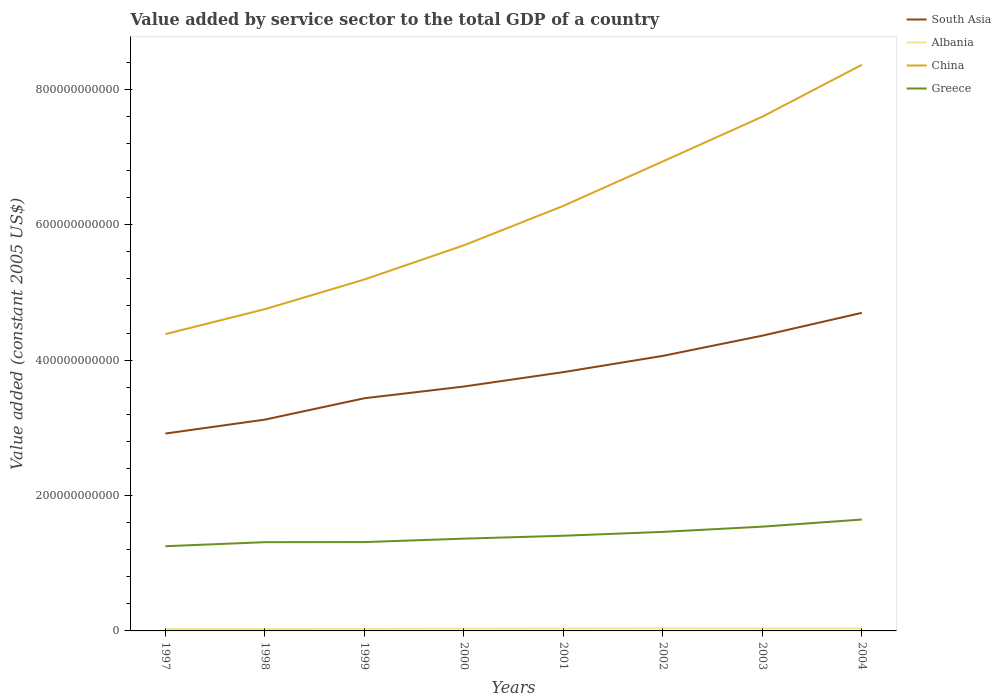Does the line corresponding to Greece intersect with the line corresponding to Albania?
Give a very brief answer. No. Is the number of lines equal to the number of legend labels?
Keep it short and to the point. Yes. Across all years, what is the maximum value added by service sector in Albania?
Give a very brief answer. 2.70e+09. What is the total value added by service sector in Greece in the graph?
Provide a succinct answer. -6.12e+09. What is the difference between the highest and the second highest value added by service sector in Albania?
Give a very brief answer. 1.13e+09. What is the difference between the highest and the lowest value added by service sector in China?
Give a very brief answer. 4. Is the value added by service sector in China strictly greater than the value added by service sector in Greece over the years?
Provide a short and direct response. No. How many years are there in the graph?
Your answer should be compact. 8. What is the difference between two consecutive major ticks on the Y-axis?
Provide a succinct answer. 2.00e+11. Are the values on the major ticks of Y-axis written in scientific E-notation?
Ensure brevity in your answer.  No. How are the legend labels stacked?
Keep it short and to the point. Vertical. What is the title of the graph?
Offer a very short reply. Value added by service sector to the total GDP of a country. What is the label or title of the Y-axis?
Keep it short and to the point. Value added (constant 2005 US$). What is the Value added (constant 2005 US$) in South Asia in 1997?
Offer a very short reply. 2.92e+11. What is the Value added (constant 2005 US$) of Albania in 1997?
Ensure brevity in your answer.  2.70e+09. What is the Value added (constant 2005 US$) of China in 1997?
Ensure brevity in your answer.  4.38e+11. What is the Value added (constant 2005 US$) of Greece in 1997?
Offer a very short reply. 1.25e+11. What is the Value added (constant 2005 US$) of South Asia in 1998?
Your answer should be very brief. 3.12e+11. What is the Value added (constant 2005 US$) in Albania in 1998?
Make the answer very short. 2.73e+09. What is the Value added (constant 2005 US$) in China in 1998?
Make the answer very short. 4.75e+11. What is the Value added (constant 2005 US$) of Greece in 1998?
Make the answer very short. 1.31e+11. What is the Value added (constant 2005 US$) of South Asia in 1999?
Your response must be concise. 3.44e+11. What is the Value added (constant 2005 US$) of Albania in 1999?
Ensure brevity in your answer.  3.14e+09. What is the Value added (constant 2005 US$) in China in 1999?
Keep it short and to the point. 5.19e+11. What is the Value added (constant 2005 US$) of Greece in 1999?
Your answer should be very brief. 1.31e+11. What is the Value added (constant 2005 US$) in South Asia in 2000?
Ensure brevity in your answer.  3.61e+11. What is the Value added (constant 2005 US$) of Albania in 2000?
Keep it short and to the point. 3.28e+09. What is the Value added (constant 2005 US$) in China in 2000?
Keep it short and to the point. 5.70e+11. What is the Value added (constant 2005 US$) of Greece in 2000?
Provide a succinct answer. 1.36e+11. What is the Value added (constant 2005 US$) in South Asia in 2001?
Offer a terse response. 3.82e+11. What is the Value added (constant 2005 US$) in Albania in 2001?
Your answer should be very brief. 3.59e+09. What is the Value added (constant 2005 US$) of China in 2001?
Provide a short and direct response. 6.28e+11. What is the Value added (constant 2005 US$) in Greece in 2001?
Keep it short and to the point. 1.41e+11. What is the Value added (constant 2005 US$) of South Asia in 2002?
Your response must be concise. 4.06e+11. What is the Value added (constant 2005 US$) of Albania in 2002?
Make the answer very short. 3.83e+09. What is the Value added (constant 2005 US$) of China in 2002?
Provide a short and direct response. 6.93e+11. What is the Value added (constant 2005 US$) of Greece in 2002?
Provide a short and direct response. 1.46e+11. What is the Value added (constant 2005 US$) in South Asia in 2003?
Keep it short and to the point. 4.36e+11. What is the Value added (constant 2005 US$) of Albania in 2003?
Your answer should be very brief. 3.63e+09. What is the Value added (constant 2005 US$) of China in 2003?
Ensure brevity in your answer.  7.60e+11. What is the Value added (constant 2005 US$) in Greece in 2003?
Ensure brevity in your answer.  1.54e+11. What is the Value added (constant 2005 US$) in South Asia in 2004?
Offer a terse response. 4.70e+11. What is the Value added (constant 2005 US$) in Albania in 2004?
Your answer should be compact. 3.64e+09. What is the Value added (constant 2005 US$) of China in 2004?
Your response must be concise. 8.36e+11. What is the Value added (constant 2005 US$) in Greece in 2004?
Your answer should be very brief. 1.65e+11. Across all years, what is the maximum Value added (constant 2005 US$) of South Asia?
Offer a terse response. 4.70e+11. Across all years, what is the maximum Value added (constant 2005 US$) in Albania?
Your answer should be compact. 3.83e+09. Across all years, what is the maximum Value added (constant 2005 US$) in China?
Provide a short and direct response. 8.36e+11. Across all years, what is the maximum Value added (constant 2005 US$) of Greece?
Your answer should be very brief. 1.65e+11. Across all years, what is the minimum Value added (constant 2005 US$) of South Asia?
Your answer should be compact. 2.92e+11. Across all years, what is the minimum Value added (constant 2005 US$) of Albania?
Provide a short and direct response. 2.70e+09. Across all years, what is the minimum Value added (constant 2005 US$) in China?
Make the answer very short. 4.38e+11. Across all years, what is the minimum Value added (constant 2005 US$) of Greece?
Your answer should be very brief. 1.25e+11. What is the total Value added (constant 2005 US$) of South Asia in the graph?
Your answer should be very brief. 3.00e+12. What is the total Value added (constant 2005 US$) in Albania in the graph?
Offer a very short reply. 2.65e+1. What is the total Value added (constant 2005 US$) in China in the graph?
Your answer should be compact. 4.92e+12. What is the total Value added (constant 2005 US$) in Greece in the graph?
Your answer should be very brief. 1.13e+12. What is the difference between the Value added (constant 2005 US$) in South Asia in 1997 and that in 1998?
Ensure brevity in your answer.  -2.06e+1. What is the difference between the Value added (constant 2005 US$) in Albania in 1997 and that in 1998?
Provide a succinct answer. -3.40e+07. What is the difference between the Value added (constant 2005 US$) in China in 1997 and that in 1998?
Offer a terse response. -3.68e+1. What is the difference between the Value added (constant 2005 US$) in Greece in 1997 and that in 1998?
Provide a short and direct response. -5.98e+09. What is the difference between the Value added (constant 2005 US$) in South Asia in 1997 and that in 1999?
Provide a short and direct response. -5.21e+1. What is the difference between the Value added (constant 2005 US$) of Albania in 1997 and that in 1999?
Ensure brevity in your answer.  -4.42e+08. What is the difference between the Value added (constant 2005 US$) of China in 1997 and that in 1999?
Offer a terse response. -8.07e+1. What is the difference between the Value added (constant 2005 US$) in Greece in 1997 and that in 1999?
Make the answer very short. -6.12e+09. What is the difference between the Value added (constant 2005 US$) of South Asia in 1997 and that in 2000?
Give a very brief answer. -6.95e+1. What is the difference between the Value added (constant 2005 US$) in Albania in 1997 and that in 2000?
Keep it short and to the point. -5.81e+08. What is the difference between the Value added (constant 2005 US$) of China in 1997 and that in 2000?
Make the answer very short. -1.31e+11. What is the difference between the Value added (constant 2005 US$) of Greece in 1997 and that in 2000?
Your answer should be very brief. -1.12e+1. What is the difference between the Value added (constant 2005 US$) of South Asia in 1997 and that in 2001?
Provide a succinct answer. -9.07e+1. What is the difference between the Value added (constant 2005 US$) of Albania in 1997 and that in 2001?
Keep it short and to the point. -8.90e+08. What is the difference between the Value added (constant 2005 US$) of China in 1997 and that in 2001?
Offer a very short reply. -1.89e+11. What is the difference between the Value added (constant 2005 US$) of Greece in 1997 and that in 2001?
Provide a short and direct response. -1.55e+1. What is the difference between the Value added (constant 2005 US$) of South Asia in 1997 and that in 2002?
Make the answer very short. -1.15e+11. What is the difference between the Value added (constant 2005 US$) in Albania in 1997 and that in 2002?
Ensure brevity in your answer.  -1.13e+09. What is the difference between the Value added (constant 2005 US$) in China in 1997 and that in 2002?
Provide a succinct answer. -2.55e+11. What is the difference between the Value added (constant 2005 US$) in Greece in 1997 and that in 2002?
Your response must be concise. -2.12e+1. What is the difference between the Value added (constant 2005 US$) in South Asia in 1997 and that in 2003?
Offer a terse response. -1.45e+11. What is the difference between the Value added (constant 2005 US$) of Albania in 1997 and that in 2003?
Your response must be concise. -9.35e+08. What is the difference between the Value added (constant 2005 US$) in China in 1997 and that in 2003?
Ensure brevity in your answer.  -3.21e+11. What is the difference between the Value added (constant 2005 US$) of Greece in 1997 and that in 2003?
Make the answer very short. -2.89e+1. What is the difference between the Value added (constant 2005 US$) in South Asia in 1997 and that in 2004?
Keep it short and to the point. -1.78e+11. What is the difference between the Value added (constant 2005 US$) of Albania in 1997 and that in 2004?
Your response must be concise. -9.43e+08. What is the difference between the Value added (constant 2005 US$) in China in 1997 and that in 2004?
Ensure brevity in your answer.  -3.98e+11. What is the difference between the Value added (constant 2005 US$) of Greece in 1997 and that in 2004?
Your response must be concise. -3.94e+1. What is the difference between the Value added (constant 2005 US$) of South Asia in 1998 and that in 1999?
Provide a short and direct response. -3.15e+1. What is the difference between the Value added (constant 2005 US$) in Albania in 1998 and that in 1999?
Provide a succinct answer. -4.08e+08. What is the difference between the Value added (constant 2005 US$) of China in 1998 and that in 1999?
Offer a very short reply. -4.38e+1. What is the difference between the Value added (constant 2005 US$) of Greece in 1998 and that in 1999?
Offer a terse response. -1.37e+08. What is the difference between the Value added (constant 2005 US$) of South Asia in 1998 and that in 2000?
Provide a succinct answer. -4.89e+1. What is the difference between the Value added (constant 2005 US$) in Albania in 1998 and that in 2000?
Give a very brief answer. -5.47e+08. What is the difference between the Value added (constant 2005 US$) of China in 1998 and that in 2000?
Your answer should be very brief. -9.43e+1. What is the difference between the Value added (constant 2005 US$) of Greece in 1998 and that in 2000?
Ensure brevity in your answer.  -5.21e+09. What is the difference between the Value added (constant 2005 US$) in South Asia in 1998 and that in 2001?
Provide a short and direct response. -7.01e+1. What is the difference between the Value added (constant 2005 US$) in Albania in 1998 and that in 2001?
Make the answer very short. -8.56e+08. What is the difference between the Value added (constant 2005 US$) in China in 1998 and that in 2001?
Offer a very short reply. -1.53e+11. What is the difference between the Value added (constant 2005 US$) in Greece in 1998 and that in 2001?
Keep it short and to the point. -9.50e+09. What is the difference between the Value added (constant 2005 US$) of South Asia in 1998 and that in 2002?
Your answer should be very brief. -9.41e+1. What is the difference between the Value added (constant 2005 US$) in Albania in 1998 and that in 2002?
Your response must be concise. -1.10e+09. What is the difference between the Value added (constant 2005 US$) of China in 1998 and that in 2002?
Ensure brevity in your answer.  -2.18e+11. What is the difference between the Value added (constant 2005 US$) of Greece in 1998 and that in 2002?
Offer a terse response. -1.52e+1. What is the difference between the Value added (constant 2005 US$) of South Asia in 1998 and that in 2003?
Offer a terse response. -1.24e+11. What is the difference between the Value added (constant 2005 US$) in Albania in 1998 and that in 2003?
Your answer should be compact. -9.01e+08. What is the difference between the Value added (constant 2005 US$) in China in 1998 and that in 2003?
Make the answer very short. -2.84e+11. What is the difference between the Value added (constant 2005 US$) in Greece in 1998 and that in 2003?
Keep it short and to the point. -2.29e+1. What is the difference between the Value added (constant 2005 US$) of South Asia in 1998 and that in 2004?
Offer a terse response. -1.58e+11. What is the difference between the Value added (constant 2005 US$) of Albania in 1998 and that in 2004?
Offer a terse response. -9.09e+08. What is the difference between the Value added (constant 2005 US$) in China in 1998 and that in 2004?
Your answer should be very brief. -3.61e+11. What is the difference between the Value added (constant 2005 US$) in Greece in 1998 and that in 2004?
Your answer should be very brief. -3.34e+1. What is the difference between the Value added (constant 2005 US$) in South Asia in 1999 and that in 2000?
Offer a terse response. -1.74e+1. What is the difference between the Value added (constant 2005 US$) in Albania in 1999 and that in 2000?
Your response must be concise. -1.39e+08. What is the difference between the Value added (constant 2005 US$) in China in 1999 and that in 2000?
Offer a very short reply. -5.05e+1. What is the difference between the Value added (constant 2005 US$) in Greece in 1999 and that in 2000?
Offer a very short reply. -5.07e+09. What is the difference between the Value added (constant 2005 US$) in South Asia in 1999 and that in 2001?
Your answer should be compact. -3.86e+1. What is the difference between the Value added (constant 2005 US$) of Albania in 1999 and that in 2001?
Give a very brief answer. -4.49e+08. What is the difference between the Value added (constant 2005 US$) of China in 1999 and that in 2001?
Your answer should be compact. -1.09e+11. What is the difference between the Value added (constant 2005 US$) of Greece in 1999 and that in 2001?
Make the answer very short. -9.36e+09. What is the difference between the Value added (constant 2005 US$) of South Asia in 1999 and that in 2002?
Your answer should be very brief. -6.26e+1. What is the difference between the Value added (constant 2005 US$) of Albania in 1999 and that in 2002?
Make the answer very short. -6.91e+08. What is the difference between the Value added (constant 2005 US$) of China in 1999 and that in 2002?
Provide a succinct answer. -1.74e+11. What is the difference between the Value added (constant 2005 US$) of Greece in 1999 and that in 2002?
Make the answer very short. -1.51e+1. What is the difference between the Value added (constant 2005 US$) in South Asia in 1999 and that in 2003?
Offer a terse response. -9.25e+1. What is the difference between the Value added (constant 2005 US$) in Albania in 1999 and that in 2003?
Offer a very short reply. -4.93e+08. What is the difference between the Value added (constant 2005 US$) of China in 1999 and that in 2003?
Your response must be concise. -2.40e+11. What is the difference between the Value added (constant 2005 US$) of Greece in 1999 and that in 2003?
Your answer should be compact. -2.28e+1. What is the difference between the Value added (constant 2005 US$) in South Asia in 1999 and that in 2004?
Offer a terse response. -1.26e+11. What is the difference between the Value added (constant 2005 US$) in Albania in 1999 and that in 2004?
Your answer should be compact. -5.02e+08. What is the difference between the Value added (constant 2005 US$) of China in 1999 and that in 2004?
Offer a very short reply. -3.17e+11. What is the difference between the Value added (constant 2005 US$) of Greece in 1999 and that in 2004?
Offer a terse response. -3.33e+1. What is the difference between the Value added (constant 2005 US$) of South Asia in 2000 and that in 2001?
Your answer should be very brief. -2.13e+1. What is the difference between the Value added (constant 2005 US$) in Albania in 2000 and that in 2001?
Your answer should be very brief. -3.10e+08. What is the difference between the Value added (constant 2005 US$) in China in 2000 and that in 2001?
Give a very brief answer. -5.83e+1. What is the difference between the Value added (constant 2005 US$) in Greece in 2000 and that in 2001?
Offer a very short reply. -4.28e+09. What is the difference between the Value added (constant 2005 US$) in South Asia in 2000 and that in 2002?
Provide a succinct answer. -4.53e+1. What is the difference between the Value added (constant 2005 US$) of Albania in 2000 and that in 2002?
Offer a terse response. -5.52e+08. What is the difference between the Value added (constant 2005 US$) in China in 2000 and that in 2002?
Keep it short and to the point. -1.24e+11. What is the difference between the Value added (constant 2005 US$) in Greece in 2000 and that in 2002?
Give a very brief answer. -1.00e+1. What is the difference between the Value added (constant 2005 US$) in South Asia in 2000 and that in 2003?
Your answer should be compact. -7.51e+1. What is the difference between the Value added (constant 2005 US$) of Albania in 2000 and that in 2003?
Offer a terse response. -3.54e+08. What is the difference between the Value added (constant 2005 US$) of China in 2000 and that in 2003?
Keep it short and to the point. -1.90e+11. What is the difference between the Value added (constant 2005 US$) in Greece in 2000 and that in 2003?
Keep it short and to the point. -1.77e+1. What is the difference between the Value added (constant 2005 US$) of South Asia in 2000 and that in 2004?
Offer a very short reply. -1.09e+11. What is the difference between the Value added (constant 2005 US$) of Albania in 2000 and that in 2004?
Offer a terse response. -3.62e+08. What is the difference between the Value added (constant 2005 US$) of China in 2000 and that in 2004?
Offer a terse response. -2.67e+11. What is the difference between the Value added (constant 2005 US$) of Greece in 2000 and that in 2004?
Provide a short and direct response. -2.82e+1. What is the difference between the Value added (constant 2005 US$) in South Asia in 2001 and that in 2002?
Offer a terse response. -2.40e+1. What is the difference between the Value added (constant 2005 US$) of Albania in 2001 and that in 2002?
Make the answer very short. -2.42e+08. What is the difference between the Value added (constant 2005 US$) of China in 2001 and that in 2002?
Give a very brief answer. -6.57e+1. What is the difference between the Value added (constant 2005 US$) in Greece in 2001 and that in 2002?
Your answer should be very brief. -5.72e+09. What is the difference between the Value added (constant 2005 US$) in South Asia in 2001 and that in 2003?
Offer a terse response. -5.39e+1. What is the difference between the Value added (constant 2005 US$) of Albania in 2001 and that in 2003?
Your response must be concise. -4.42e+07. What is the difference between the Value added (constant 2005 US$) of China in 2001 and that in 2003?
Your response must be concise. -1.32e+11. What is the difference between the Value added (constant 2005 US$) in Greece in 2001 and that in 2003?
Your answer should be very brief. -1.34e+1. What is the difference between the Value added (constant 2005 US$) of South Asia in 2001 and that in 2004?
Give a very brief answer. -8.76e+1. What is the difference between the Value added (constant 2005 US$) of Albania in 2001 and that in 2004?
Your answer should be very brief. -5.27e+07. What is the difference between the Value added (constant 2005 US$) of China in 2001 and that in 2004?
Your response must be concise. -2.08e+11. What is the difference between the Value added (constant 2005 US$) in Greece in 2001 and that in 2004?
Your answer should be compact. -2.40e+1. What is the difference between the Value added (constant 2005 US$) of South Asia in 2002 and that in 2003?
Your answer should be very brief. -2.99e+1. What is the difference between the Value added (constant 2005 US$) in Albania in 2002 and that in 2003?
Offer a very short reply. 1.98e+08. What is the difference between the Value added (constant 2005 US$) of China in 2002 and that in 2003?
Your response must be concise. -6.61e+1. What is the difference between the Value added (constant 2005 US$) of Greece in 2002 and that in 2003?
Keep it short and to the point. -7.70e+09. What is the difference between the Value added (constant 2005 US$) of South Asia in 2002 and that in 2004?
Your response must be concise. -6.36e+1. What is the difference between the Value added (constant 2005 US$) of Albania in 2002 and that in 2004?
Make the answer very short. 1.90e+08. What is the difference between the Value added (constant 2005 US$) in China in 2002 and that in 2004?
Your response must be concise. -1.43e+11. What is the difference between the Value added (constant 2005 US$) of Greece in 2002 and that in 2004?
Offer a terse response. -1.82e+1. What is the difference between the Value added (constant 2005 US$) in South Asia in 2003 and that in 2004?
Offer a terse response. -3.37e+1. What is the difference between the Value added (constant 2005 US$) of Albania in 2003 and that in 2004?
Your answer should be compact. -8.49e+06. What is the difference between the Value added (constant 2005 US$) of China in 2003 and that in 2004?
Provide a succinct answer. -7.66e+1. What is the difference between the Value added (constant 2005 US$) in Greece in 2003 and that in 2004?
Keep it short and to the point. -1.05e+1. What is the difference between the Value added (constant 2005 US$) in South Asia in 1997 and the Value added (constant 2005 US$) in Albania in 1998?
Keep it short and to the point. 2.89e+11. What is the difference between the Value added (constant 2005 US$) of South Asia in 1997 and the Value added (constant 2005 US$) of China in 1998?
Give a very brief answer. -1.84e+11. What is the difference between the Value added (constant 2005 US$) of South Asia in 1997 and the Value added (constant 2005 US$) of Greece in 1998?
Provide a short and direct response. 1.60e+11. What is the difference between the Value added (constant 2005 US$) of Albania in 1997 and the Value added (constant 2005 US$) of China in 1998?
Offer a very short reply. -4.73e+11. What is the difference between the Value added (constant 2005 US$) of Albania in 1997 and the Value added (constant 2005 US$) of Greece in 1998?
Offer a very short reply. -1.28e+11. What is the difference between the Value added (constant 2005 US$) in China in 1997 and the Value added (constant 2005 US$) in Greece in 1998?
Provide a short and direct response. 3.07e+11. What is the difference between the Value added (constant 2005 US$) in South Asia in 1997 and the Value added (constant 2005 US$) in Albania in 1999?
Ensure brevity in your answer.  2.88e+11. What is the difference between the Value added (constant 2005 US$) in South Asia in 1997 and the Value added (constant 2005 US$) in China in 1999?
Your response must be concise. -2.28e+11. What is the difference between the Value added (constant 2005 US$) in South Asia in 1997 and the Value added (constant 2005 US$) in Greece in 1999?
Ensure brevity in your answer.  1.60e+11. What is the difference between the Value added (constant 2005 US$) of Albania in 1997 and the Value added (constant 2005 US$) of China in 1999?
Offer a terse response. -5.16e+11. What is the difference between the Value added (constant 2005 US$) of Albania in 1997 and the Value added (constant 2005 US$) of Greece in 1999?
Keep it short and to the point. -1.29e+11. What is the difference between the Value added (constant 2005 US$) of China in 1997 and the Value added (constant 2005 US$) of Greece in 1999?
Keep it short and to the point. 3.07e+11. What is the difference between the Value added (constant 2005 US$) in South Asia in 1997 and the Value added (constant 2005 US$) in Albania in 2000?
Your answer should be compact. 2.88e+11. What is the difference between the Value added (constant 2005 US$) in South Asia in 1997 and the Value added (constant 2005 US$) in China in 2000?
Provide a short and direct response. -2.78e+11. What is the difference between the Value added (constant 2005 US$) of South Asia in 1997 and the Value added (constant 2005 US$) of Greece in 2000?
Your answer should be compact. 1.55e+11. What is the difference between the Value added (constant 2005 US$) in Albania in 1997 and the Value added (constant 2005 US$) in China in 2000?
Your answer should be very brief. -5.67e+11. What is the difference between the Value added (constant 2005 US$) in Albania in 1997 and the Value added (constant 2005 US$) in Greece in 2000?
Keep it short and to the point. -1.34e+11. What is the difference between the Value added (constant 2005 US$) in China in 1997 and the Value added (constant 2005 US$) in Greece in 2000?
Your answer should be very brief. 3.02e+11. What is the difference between the Value added (constant 2005 US$) in South Asia in 1997 and the Value added (constant 2005 US$) in Albania in 2001?
Provide a short and direct response. 2.88e+11. What is the difference between the Value added (constant 2005 US$) of South Asia in 1997 and the Value added (constant 2005 US$) of China in 2001?
Keep it short and to the point. -3.36e+11. What is the difference between the Value added (constant 2005 US$) of South Asia in 1997 and the Value added (constant 2005 US$) of Greece in 2001?
Keep it short and to the point. 1.51e+11. What is the difference between the Value added (constant 2005 US$) of Albania in 1997 and the Value added (constant 2005 US$) of China in 2001?
Your response must be concise. -6.25e+11. What is the difference between the Value added (constant 2005 US$) in Albania in 1997 and the Value added (constant 2005 US$) in Greece in 2001?
Keep it short and to the point. -1.38e+11. What is the difference between the Value added (constant 2005 US$) in China in 1997 and the Value added (constant 2005 US$) in Greece in 2001?
Offer a very short reply. 2.98e+11. What is the difference between the Value added (constant 2005 US$) in South Asia in 1997 and the Value added (constant 2005 US$) in Albania in 2002?
Your answer should be compact. 2.88e+11. What is the difference between the Value added (constant 2005 US$) of South Asia in 1997 and the Value added (constant 2005 US$) of China in 2002?
Give a very brief answer. -4.02e+11. What is the difference between the Value added (constant 2005 US$) of South Asia in 1997 and the Value added (constant 2005 US$) of Greece in 2002?
Your answer should be compact. 1.45e+11. What is the difference between the Value added (constant 2005 US$) of Albania in 1997 and the Value added (constant 2005 US$) of China in 2002?
Make the answer very short. -6.91e+11. What is the difference between the Value added (constant 2005 US$) of Albania in 1997 and the Value added (constant 2005 US$) of Greece in 2002?
Offer a very short reply. -1.44e+11. What is the difference between the Value added (constant 2005 US$) in China in 1997 and the Value added (constant 2005 US$) in Greece in 2002?
Make the answer very short. 2.92e+11. What is the difference between the Value added (constant 2005 US$) of South Asia in 1997 and the Value added (constant 2005 US$) of Albania in 2003?
Provide a succinct answer. 2.88e+11. What is the difference between the Value added (constant 2005 US$) in South Asia in 1997 and the Value added (constant 2005 US$) in China in 2003?
Ensure brevity in your answer.  -4.68e+11. What is the difference between the Value added (constant 2005 US$) in South Asia in 1997 and the Value added (constant 2005 US$) in Greece in 2003?
Offer a very short reply. 1.38e+11. What is the difference between the Value added (constant 2005 US$) of Albania in 1997 and the Value added (constant 2005 US$) of China in 2003?
Keep it short and to the point. -7.57e+11. What is the difference between the Value added (constant 2005 US$) in Albania in 1997 and the Value added (constant 2005 US$) in Greece in 2003?
Make the answer very short. -1.51e+11. What is the difference between the Value added (constant 2005 US$) in China in 1997 and the Value added (constant 2005 US$) in Greece in 2003?
Keep it short and to the point. 2.84e+11. What is the difference between the Value added (constant 2005 US$) of South Asia in 1997 and the Value added (constant 2005 US$) of Albania in 2004?
Keep it short and to the point. 2.88e+11. What is the difference between the Value added (constant 2005 US$) of South Asia in 1997 and the Value added (constant 2005 US$) of China in 2004?
Provide a short and direct response. -5.45e+11. What is the difference between the Value added (constant 2005 US$) of South Asia in 1997 and the Value added (constant 2005 US$) of Greece in 2004?
Give a very brief answer. 1.27e+11. What is the difference between the Value added (constant 2005 US$) in Albania in 1997 and the Value added (constant 2005 US$) in China in 2004?
Your response must be concise. -8.34e+11. What is the difference between the Value added (constant 2005 US$) of Albania in 1997 and the Value added (constant 2005 US$) of Greece in 2004?
Your answer should be compact. -1.62e+11. What is the difference between the Value added (constant 2005 US$) in China in 1997 and the Value added (constant 2005 US$) in Greece in 2004?
Ensure brevity in your answer.  2.74e+11. What is the difference between the Value added (constant 2005 US$) in South Asia in 1998 and the Value added (constant 2005 US$) in Albania in 1999?
Provide a succinct answer. 3.09e+11. What is the difference between the Value added (constant 2005 US$) in South Asia in 1998 and the Value added (constant 2005 US$) in China in 1999?
Provide a short and direct response. -2.07e+11. What is the difference between the Value added (constant 2005 US$) of South Asia in 1998 and the Value added (constant 2005 US$) of Greece in 1999?
Ensure brevity in your answer.  1.81e+11. What is the difference between the Value added (constant 2005 US$) in Albania in 1998 and the Value added (constant 2005 US$) in China in 1999?
Give a very brief answer. -5.16e+11. What is the difference between the Value added (constant 2005 US$) of Albania in 1998 and the Value added (constant 2005 US$) of Greece in 1999?
Provide a succinct answer. -1.28e+11. What is the difference between the Value added (constant 2005 US$) in China in 1998 and the Value added (constant 2005 US$) in Greece in 1999?
Keep it short and to the point. 3.44e+11. What is the difference between the Value added (constant 2005 US$) in South Asia in 1998 and the Value added (constant 2005 US$) in Albania in 2000?
Provide a succinct answer. 3.09e+11. What is the difference between the Value added (constant 2005 US$) of South Asia in 1998 and the Value added (constant 2005 US$) of China in 2000?
Offer a terse response. -2.57e+11. What is the difference between the Value added (constant 2005 US$) of South Asia in 1998 and the Value added (constant 2005 US$) of Greece in 2000?
Ensure brevity in your answer.  1.76e+11. What is the difference between the Value added (constant 2005 US$) of Albania in 1998 and the Value added (constant 2005 US$) of China in 2000?
Provide a succinct answer. -5.67e+11. What is the difference between the Value added (constant 2005 US$) of Albania in 1998 and the Value added (constant 2005 US$) of Greece in 2000?
Your response must be concise. -1.34e+11. What is the difference between the Value added (constant 2005 US$) in China in 1998 and the Value added (constant 2005 US$) in Greece in 2000?
Your answer should be very brief. 3.39e+11. What is the difference between the Value added (constant 2005 US$) of South Asia in 1998 and the Value added (constant 2005 US$) of Albania in 2001?
Your answer should be very brief. 3.09e+11. What is the difference between the Value added (constant 2005 US$) of South Asia in 1998 and the Value added (constant 2005 US$) of China in 2001?
Your answer should be compact. -3.16e+11. What is the difference between the Value added (constant 2005 US$) in South Asia in 1998 and the Value added (constant 2005 US$) in Greece in 2001?
Offer a very short reply. 1.72e+11. What is the difference between the Value added (constant 2005 US$) in Albania in 1998 and the Value added (constant 2005 US$) in China in 2001?
Give a very brief answer. -6.25e+11. What is the difference between the Value added (constant 2005 US$) of Albania in 1998 and the Value added (constant 2005 US$) of Greece in 2001?
Your response must be concise. -1.38e+11. What is the difference between the Value added (constant 2005 US$) of China in 1998 and the Value added (constant 2005 US$) of Greece in 2001?
Provide a succinct answer. 3.35e+11. What is the difference between the Value added (constant 2005 US$) in South Asia in 1998 and the Value added (constant 2005 US$) in Albania in 2002?
Your response must be concise. 3.08e+11. What is the difference between the Value added (constant 2005 US$) of South Asia in 1998 and the Value added (constant 2005 US$) of China in 2002?
Provide a short and direct response. -3.81e+11. What is the difference between the Value added (constant 2005 US$) in South Asia in 1998 and the Value added (constant 2005 US$) in Greece in 2002?
Your answer should be very brief. 1.66e+11. What is the difference between the Value added (constant 2005 US$) of Albania in 1998 and the Value added (constant 2005 US$) of China in 2002?
Give a very brief answer. -6.91e+11. What is the difference between the Value added (constant 2005 US$) in Albania in 1998 and the Value added (constant 2005 US$) in Greece in 2002?
Offer a very short reply. -1.44e+11. What is the difference between the Value added (constant 2005 US$) in China in 1998 and the Value added (constant 2005 US$) in Greece in 2002?
Make the answer very short. 3.29e+11. What is the difference between the Value added (constant 2005 US$) of South Asia in 1998 and the Value added (constant 2005 US$) of Albania in 2003?
Give a very brief answer. 3.08e+11. What is the difference between the Value added (constant 2005 US$) in South Asia in 1998 and the Value added (constant 2005 US$) in China in 2003?
Keep it short and to the point. -4.47e+11. What is the difference between the Value added (constant 2005 US$) in South Asia in 1998 and the Value added (constant 2005 US$) in Greece in 2003?
Your answer should be very brief. 1.58e+11. What is the difference between the Value added (constant 2005 US$) of Albania in 1998 and the Value added (constant 2005 US$) of China in 2003?
Provide a succinct answer. -7.57e+11. What is the difference between the Value added (constant 2005 US$) of Albania in 1998 and the Value added (constant 2005 US$) of Greece in 2003?
Offer a terse response. -1.51e+11. What is the difference between the Value added (constant 2005 US$) of China in 1998 and the Value added (constant 2005 US$) of Greece in 2003?
Keep it short and to the point. 3.21e+11. What is the difference between the Value added (constant 2005 US$) of South Asia in 1998 and the Value added (constant 2005 US$) of Albania in 2004?
Ensure brevity in your answer.  3.08e+11. What is the difference between the Value added (constant 2005 US$) in South Asia in 1998 and the Value added (constant 2005 US$) in China in 2004?
Your response must be concise. -5.24e+11. What is the difference between the Value added (constant 2005 US$) of South Asia in 1998 and the Value added (constant 2005 US$) of Greece in 2004?
Your response must be concise. 1.48e+11. What is the difference between the Value added (constant 2005 US$) in Albania in 1998 and the Value added (constant 2005 US$) in China in 2004?
Your answer should be compact. -8.33e+11. What is the difference between the Value added (constant 2005 US$) of Albania in 1998 and the Value added (constant 2005 US$) of Greece in 2004?
Ensure brevity in your answer.  -1.62e+11. What is the difference between the Value added (constant 2005 US$) of China in 1998 and the Value added (constant 2005 US$) of Greece in 2004?
Make the answer very short. 3.11e+11. What is the difference between the Value added (constant 2005 US$) of South Asia in 1999 and the Value added (constant 2005 US$) of Albania in 2000?
Ensure brevity in your answer.  3.40e+11. What is the difference between the Value added (constant 2005 US$) in South Asia in 1999 and the Value added (constant 2005 US$) in China in 2000?
Ensure brevity in your answer.  -2.26e+11. What is the difference between the Value added (constant 2005 US$) in South Asia in 1999 and the Value added (constant 2005 US$) in Greece in 2000?
Provide a short and direct response. 2.07e+11. What is the difference between the Value added (constant 2005 US$) of Albania in 1999 and the Value added (constant 2005 US$) of China in 2000?
Keep it short and to the point. -5.66e+11. What is the difference between the Value added (constant 2005 US$) in Albania in 1999 and the Value added (constant 2005 US$) in Greece in 2000?
Your response must be concise. -1.33e+11. What is the difference between the Value added (constant 2005 US$) in China in 1999 and the Value added (constant 2005 US$) in Greece in 2000?
Your answer should be compact. 3.83e+11. What is the difference between the Value added (constant 2005 US$) in South Asia in 1999 and the Value added (constant 2005 US$) in Albania in 2001?
Give a very brief answer. 3.40e+11. What is the difference between the Value added (constant 2005 US$) of South Asia in 1999 and the Value added (constant 2005 US$) of China in 2001?
Provide a short and direct response. -2.84e+11. What is the difference between the Value added (constant 2005 US$) of South Asia in 1999 and the Value added (constant 2005 US$) of Greece in 2001?
Ensure brevity in your answer.  2.03e+11. What is the difference between the Value added (constant 2005 US$) in Albania in 1999 and the Value added (constant 2005 US$) in China in 2001?
Ensure brevity in your answer.  -6.25e+11. What is the difference between the Value added (constant 2005 US$) of Albania in 1999 and the Value added (constant 2005 US$) of Greece in 2001?
Your answer should be compact. -1.37e+11. What is the difference between the Value added (constant 2005 US$) in China in 1999 and the Value added (constant 2005 US$) in Greece in 2001?
Your answer should be compact. 3.78e+11. What is the difference between the Value added (constant 2005 US$) of South Asia in 1999 and the Value added (constant 2005 US$) of Albania in 2002?
Your response must be concise. 3.40e+11. What is the difference between the Value added (constant 2005 US$) of South Asia in 1999 and the Value added (constant 2005 US$) of China in 2002?
Keep it short and to the point. -3.50e+11. What is the difference between the Value added (constant 2005 US$) in South Asia in 1999 and the Value added (constant 2005 US$) in Greece in 2002?
Your response must be concise. 1.97e+11. What is the difference between the Value added (constant 2005 US$) of Albania in 1999 and the Value added (constant 2005 US$) of China in 2002?
Your answer should be very brief. -6.90e+11. What is the difference between the Value added (constant 2005 US$) in Albania in 1999 and the Value added (constant 2005 US$) in Greece in 2002?
Give a very brief answer. -1.43e+11. What is the difference between the Value added (constant 2005 US$) of China in 1999 and the Value added (constant 2005 US$) of Greece in 2002?
Make the answer very short. 3.73e+11. What is the difference between the Value added (constant 2005 US$) of South Asia in 1999 and the Value added (constant 2005 US$) of Albania in 2003?
Keep it short and to the point. 3.40e+11. What is the difference between the Value added (constant 2005 US$) of South Asia in 1999 and the Value added (constant 2005 US$) of China in 2003?
Make the answer very short. -4.16e+11. What is the difference between the Value added (constant 2005 US$) of South Asia in 1999 and the Value added (constant 2005 US$) of Greece in 2003?
Provide a succinct answer. 1.90e+11. What is the difference between the Value added (constant 2005 US$) of Albania in 1999 and the Value added (constant 2005 US$) of China in 2003?
Offer a very short reply. -7.56e+11. What is the difference between the Value added (constant 2005 US$) of Albania in 1999 and the Value added (constant 2005 US$) of Greece in 2003?
Give a very brief answer. -1.51e+11. What is the difference between the Value added (constant 2005 US$) in China in 1999 and the Value added (constant 2005 US$) in Greece in 2003?
Give a very brief answer. 3.65e+11. What is the difference between the Value added (constant 2005 US$) of South Asia in 1999 and the Value added (constant 2005 US$) of Albania in 2004?
Your response must be concise. 3.40e+11. What is the difference between the Value added (constant 2005 US$) of South Asia in 1999 and the Value added (constant 2005 US$) of China in 2004?
Make the answer very short. -4.93e+11. What is the difference between the Value added (constant 2005 US$) in South Asia in 1999 and the Value added (constant 2005 US$) in Greece in 2004?
Offer a terse response. 1.79e+11. What is the difference between the Value added (constant 2005 US$) in Albania in 1999 and the Value added (constant 2005 US$) in China in 2004?
Keep it short and to the point. -8.33e+11. What is the difference between the Value added (constant 2005 US$) in Albania in 1999 and the Value added (constant 2005 US$) in Greece in 2004?
Your response must be concise. -1.61e+11. What is the difference between the Value added (constant 2005 US$) in China in 1999 and the Value added (constant 2005 US$) in Greece in 2004?
Your answer should be very brief. 3.55e+11. What is the difference between the Value added (constant 2005 US$) in South Asia in 2000 and the Value added (constant 2005 US$) in Albania in 2001?
Provide a succinct answer. 3.57e+11. What is the difference between the Value added (constant 2005 US$) of South Asia in 2000 and the Value added (constant 2005 US$) of China in 2001?
Your answer should be compact. -2.67e+11. What is the difference between the Value added (constant 2005 US$) in South Asia in 2000 and the Value added (constant 2005 US$) in Greece in 2001?
Offer a terse response. 2.20e+11. What is the difference between the Value added (constant 2005 US$) in Albania in 2000 and the Value added (constant 2005 US$) in China in 2001?
Your answer should be compact. -6.25e+11. What is the difference between the Value added (constant 2005 US$) in Albania in 2000 and the Value added (constant 2005 US$) in Greece in 2001?
Your answer should be very brief. -1.37e+11. What is the difference between the Value added (constant 2005 US$) in China in 2000 and the Value added (constant 2005 US$) in Greece in 2001?
Your answer should be compact. 4.29e+11. What is the difference between the Value added (constant 2005 US$) of South Asia in 2000 and the Value added (constant 2005 US$) of Albania in 2002?
Ensure brevity in your answer.  3.57e+11. What is the difference between the Value added (constant 2005 US$) in South Asia in 2000 and the Value added (constant 2005 US$) in China in 2002?
Make the answer very short. -3.32e+11. What is the difference between the Value added (constant 2005 US$) of South Asia in 2000 and the Value added (constant 2005 US$) of Greece in 2002?
Give a very brief answer. 2.15e+11. What is the difference between the Value added (constant 2005 US$) in Albania in 2000 and the Value added (constant 2005 US$) in China in 2002?
Your response must be concise. -6.90e+11. What is the difference between the Value added (constant 2005 US$) of Albania in 2000 and the Value added (constant 2005 US$) of Greece in 2002?
Provide a succinct answer. -1.43e+11. What is the difference between the Value added (constant 2005 US$) of China in 2000 and the Value added (constant 2005 US$) of Greece in 2002?
Give a very brief answer. 4.23e+11. What is the difference between the Value added (constant 2005 US$) in South Asia in 2000 and the Value added (constant 2005 US$) in Albania in 2003?
Ensure brevity in your answer.  3.57e+11. What is the difference between the Value added (constant 2005 US$) of South Asia in 2000 and the Value added (constant 2005 US$) of China in 2003?
Offer a terse response. -3.99e+11. What is the difference between the Value added (constant 2005 US$) of South Asia in 2000 and the Value added (constant 2005 US$) of Greece in 2003?
Keep it short and to the point. 2.07e+11. What is the difference between the Value added (constant 2005 US$) of Albania in 2000 and the Value added (constant 2005 US$) of China in 2003?
Keep it short and to the point. -7.56e+11. What is the difference between the Value added (constant 2005 US$) in Albania in 2000 and the Value added (constant 2005 US$) in Greece in 2003?
Offer a terse response. -1.51e+11. What is the difference between the Value added (constant 2005 US$) of China in 2000 and the Value added (constant 2005 US$) of Greece in 2003?
Keep it short and to the point. 4.16e+11. What is the difference between the Value added (constant 2005 US$) in South Asia in 2000 and the Value added (constant 2005 US$) in Albania in 2004?
Your answer should be very brief. 3.57e+11. What is the difference between the Value added (constant 2005 US$) of South Asia in 2000 and the Value added (constant 2005 US$) of China in 2004?
Provide a succinct answer. -4.75e+11. What is the difference between the Value added (constant 2005 US$) in South Asia in 2000 and the Value added (constant 2005 US$) in Greece in 2004?
Provide a short and direct response. 1.96e+11. What is the difference between the Value added (constant 2005 US$) of Albania in 2000 and the Value added (constant 2005 US$) of China in 2004?
Your answer should be very brief. -8.33e+11. What is the difference between the Value added (constant 2005 US$) in Albania in 2000 and the Value added (constant 2005 US$) in Greece in 2004?
Your answer should be very brief. -1.61e+11. What is the difference between the Value added (constant 2005 US$) in China in 2000 and the Value added (constant 2005 US$) in Greece in 2004?
Your answer should be very brief. 4.05e+11. What is the difference between the Value added (constant 2005 US$) in South Asia in 2001 and the Value added (constant 2005 US$) in Albania in 2002?
Ensure brevity in your answer.  3.78e+11. What is the difference between the Value added (constant 2005 US$) of South Asia in 2001 and the Value added (constant 2005 US$) of China in 2002?
Offer a terse response. -3.11e+11. What is the difference between the Value added (constant 2005 US$) in South Asia in 2001 and the Value added (constant 2005 US$) in Greece in 2002?
Keep it short and to the point. 2.36e+11. What is the difference between the Value added (constant 2005 US$) in Albania in 2001 and the Value added (constant 2005 US$) in China in 2002?
Offer a very short reply. -6.90e+11. What is the difference between the Value added (constant 2005 US$) of Albania in 2001 and the Value added (constant 2005 US$) of Greece in 2002?
Provide a succinct answer. -1.43e+11. What is the difference between the Value added (constant 2005 US$) of China in 2001 and the Value added (constant 2005 US$) of Greece in 2002?
Your answer should be compact. 4.82e+11. What is the difference between the Value added (constant 2005 US$) of South Asia in 2001 and the Value added (constant 2005 US$) of Albania in 2003?
Make the answer very short. 3.79e+11. What is the difference between the Value added (constant 2005 US$) in South Asia in 2001 and the Value added (constant 2005 US$) in China in 2003?
Ensure brevity in your answer.  -3.77e+11. What is the difference between the Value added (constant 2005 US$) in South Asia in 2001 and the Value added (constant 2005 US$) in Greece in 2003?
Offer a terse response. 2.28e+11. What is the difference between the Value added (constant 2005 US$) of Albania in 2001 and the Value added (constant 2005 US$) of China in 2003?
Give a very brief answer. -7.56e+11. What is the difference between the Value added (constant 2005 US$) of Albania in 2001 and the Value added (constant 2005 US$) of Greece in 2003?
Ensure brevity in your answer.  -1.50e+11. What is the difference between the Value added (constant 2005 US$) in China in 2001 and the Value added (constant 2005 US$) in Greece in 2003?
Provide a short and direct response. 4.74e+11. What is the difference between the Value added (constant 2005 US$) of South Asia in 2001 and the Value added (constant 2005 US$) of Albania in 2004?
Keep it short and to the point. 3.79e+11. What is the difference between the Value added (constant 2005 US$) in South Asia in 2001 and the Value added (constant 2005 US$) in China in 2004?
Provide a short and direct response. -4.54e+11. What is the difference between the Value added (constant 2005 US$) in South Asia in 2001 and the Value added (constant 2005 US$) in Greece in 2004?
Your answer should be compact. 2.18e+11. What is the difference between the Value added (constant 2005 US$) in Albania in 2001 and the Value added (constant 2005 US$) in China in 2004?
Give a very brief answer. -8.33e+11. What is the difference between the Value added (constant 2005 US$) in Albania in 2001 and the Value added (constant 2005 US$) in Greece in 2004?
Keep it short and to the point. -1.61e+11. What is the difference between the Value added (constant 2005 US$) of China in 2001 and the Value added (constant 2005 US$) of Greece in 2004?
Ensure brevity in your answer.  4.63e+11. What is the difference between the Value added (constant 2005 US$) in South Asia in 2002 and the Value added (constant 2005 US$) in Albania in 2003?
Your answer should be compact. 4.03e+11. What is the difference between the Value added (constant 2005 US$) of South Asia in 2002 and the Value added (constant 2005 US$) of China in 2003?
Your answer should be very brief. -3.53e+11. What is the difference between the Value added (constant 2005 US$) in South Asia in 2002 and the Value added (constant 2005 US$) in Greece in 2003?
Give a very brief answer. 2.52e+11. What is the difference between the Value added (constant 2005 US$) of Albania in 2002 and the Value added (constant 2005 US$) of China in 2003?
Your answer should be very brief. -7.56e+11. What is the difference between the Value added (constant 2005 US$) of Albania in 2002 and the Value added (constant 2005 US$) of Greece in 2003?
Your answer should be very brief. -1.50e+11. What is the difference between the Value added (constant 2005 US$) in China in 2002 and the Value added (constant 2005 US$) in Greece in 2003?
Provide a short and direct response. 5.39e+11. What is the difference between the Value added (constant 2005 US$) of South Asia in 2002 and the Value added (constant 2005 US$) of Albania in 2004?
Your response must be concise. 4.03e+11. What is the difference between the Value added (constant 2005 US$) in South Asia in 2002 and the Value added (constant 2005 US$) in China in 2004?
Offer a terse response. -4.30e+11. What is the difference between the Value added (constant 2005 US$) in South Asia in 2002 and the Value added (constant 2005 US$) in Greece in 2004?
Give a very brief answer. 2.42e+11. What is the difference between the Value added (constant 2005 US$) of Albania in 2002 and the Value added (constant 2005 US$) of China in 2004?
Offer a terse response. -8.32e+11. What is the difference between the Value added (constant 2005 US$) in Albania in 2002 and the Value added (constant 2005 US$) in Greece in 2004?
Provide a short and direct response. -1.61e+11. What is the difference between the Value added (constant 2005 US$) in China in 2002 and the Value added (constant 2005 US$) in Greece in 2004?
Your response must be concise. 5.29e+11. What is the difference between the Value added (constant 2005 US$) in South Asia in 2003 and the Value added (constant 2005 US$) in Albania in 2004?
Ensure brevity in your answer.  4.32e+11. What is the difference between the Value added (constant 2005 US$) of South Asia in 2003 and the Value added (constant 2005 US$) of China in 2004?
Your answer should be compact. -4.00e+11. What is the difference between the Value added (constant 2005 US$) in South Asia in 2003 and the Value added (constant 2005 US$) in Greece in 2004?
Make the answer very short. 2.72e+11. What is the difference between the Value added (constant 2005 US$) in Albania in 2003 and the Value added (constant 2005 US$) in China in 2004?
Your answer should be very brief. -8.33e+11. What is the difference between the Value added (constant 2005 US$) of Albania in 2003 and the Value added (constant 2005 US$) of Greece in 2004?
Provide a short and direct response. -1.61e+11. What is the difference between the Value added (constant 2005 US$) in China in 2003 and the Value added (constant 2005 US$) in Greece in 2004?
Offer a terse response. 5.95e+11. What is the average Value added (constant 2005 US$) in South Asia per year?
Provide a succinct answer. 3.75e+11. What is the average Value added (constant 2005 US$) in Albania per year?
Provide a short and direct response. 3.32e+09. What is the average Value added (constant 2005 US$) of China per year?
Offer a very short reply. 6.15e+11. What is the average Value added (constant 2005 US$) in Greece per year?
Your response must be concise. 1.41e+11. In the year 1997, what is the difference between the Value added (constant 2005 US$) in South Asia and Value added (constant 2005 US$) in Albania?
Provide a short and direct response. 2.89e+11. In the year 1997, what is the difference between the Value added (constant 2005 US$) of South Asia and Value added (constant 2005 US$) of China?
Offer a very short reply. -1.47e+11. In the year 1997, what is the difference between the Value added (constant 2005 US$) of South Asia and Value added (constant 2005 US$) of Greece?
Keep it short and to the point. 1.66e+11. In the year 1997, what is the difference between the Value added (constant 2005 US$) of Albania and Value added (constant 2005 US$) of China?
Ensure brevity in your answer.  -4.36e+11. In the year 1997, what is the difference between the Value added (constant 2005 US$) of Albania and Value added (constant 2005 US$) of Greece?
Your answer should be very brief. -1.22e+11. In the year 1997, what is the difference between the Value added (constant 2005 US$) in China and Value added (constant 2005 US$) in Greece?
Offer a very short reply. 3.13e+11. In the year 1998, what is the difference between the Value added (constant 2005 US$) of South Asia and Value added (constant 2005 US$) of Albania?
Give a very brief answer. 3.09e+11. In the year 1998, what is the difference between the Value added (constant 2005 US$) of South Asia and Value added (constant 2005 US$) of China?
Provide a succinct answer. -1.63e+11. In the year 1998, what is the difference between the Value added (constant 2005 US$) of South Asia and Value added (constant 2005 US$) of Greece?
Your answer should be very brief. 1.81e+11. In the year 1998, what is the difference between the Value added (constant 2005 US$) in Albania and Value added (constant 2005 US$) in China?
Your answer should be very brief. -4.73e+11. In the year 1998, what is the difference between the Value added (constant 2005 US$) of Albania and Value added (constant 2005 US$) of Greece?
Your answer should be very brief. -1.28e+11. In the year 1998, what is the difference between the Value added (constant 2005 US$) of China and Value added (constant 2005 US$) of Greece?
Your response must be concise. 3.44e+11. In the year 1999, what is the difference between the Value added (constant 2005 US$) in South Asia and Value added (constant 2005 US$) in Albania?
Provide a succinct answer. 3.41e+11. In the year 1999, what is the difference between the Value added (constant 2005 US$) of South Asia and Value added (constant 2005 US$) of China?
Offer a terse response. -1.75e+11. In the year 1999, what is the difference between the Value added (constant 2005 US$) of South Asia and Value added (constant 2005 US$) of Greece?
Your response must be concise. 2.12e+11. In the year 1999, what is the difference between the Value added (constant 2005 US$) of Albania and Value added (constant 2005 US$) of China?
Ensure brevity in your answer.  -5.16e+11. In the year 1999, what is the difference between the Value added (constant 2005 US$) in Albania and Value added (constant 2005 US$) in Greece?
Offer a very short reply. -1.28e+11. In the year 1999, what is the difference between the Value added (constant 2005 US$) of China and Value added (constant 2005 US$) of Greece?
Ensure brevity in your answer.  3.88e+11. In the year 2000, what is the difference between the Value added (constant 2005 US$) in South Asia and Value added (constant 2005 US$) in Albania?
Your answer should be very brief. 3.58e+11. In the year 2000, what is the difference between the Value added (constant 2005 US$) of South Asia and Value added (constant 2005 US$) of China?
Ensure brevity in your answer.  -2.09e+11. In the year 2000, what is the difference between the Value added (constant 2005 US$) of South Asia and Value added (constant 2005 US$) of Greece?
Ensure brevity in your answer.  2.25e+11. In the year 2000, what is the difference between the Value added (constant 2005 US$) in Albania and Value added (constant 2005 US$) in China?
Your answer should be compact. -5.66e+11. In the year 2000, what is the difference between the Value added (constant 2005 US$) of Albania and Value added (constant 2005 US$) of Greece?
Your response must be concise. -1.33e+11. In the year 2000, what is the difference between the Value added (constant 2005 US$) of China and Value added (constant 2005 US$) of Greece?
Ensure brevity in your answer.  4.33e+11. In the year 2001, what is the difference between the Value added (constant 2005 US$) of South Asia and Value added (constant 2005 US$) of Albania?
Offer a terse response. 3.79e+11. In the year 2001, what is the difference between the Value added (constant 2005 US$) of South Asia and Value added (constant 2005 US$) of China?
Ensure brevity in your answer.  -2.46e+11. In the year 2001, what is the difference between the Value added (constant 2005 US$) in South Asia and Value added (constant 2005 US$) in Greece?
Your answer should be very brief. 2.42e+11. In the year 2001, what is the difference between the Value added (constant 2005 US$) of Albania and Value added (constant 2005 US$) of China?
Provide a succinct answer. -6.24e+11. In the year 2001, what is the difference between the Value added (constant 2005 US$) of Albania and Value added (constant 2005 US$) of Greece?
Provide a succinct answer. -1.37e+11. In the year 2001, what is the difference between the Value added (constant 2005 US$) of China and Value added (constant 2005 US$) of Greece?
Give a very brief answer. 4.87e+11. In the year 2002, what is the difference between the Value added (constant 2005 US$) of South Asia and Value added (constant 2005 US$) of Albania?
Provide a short and direct response. 4.02e+11. In the year 2002, what is the difference between the Value added (constant 2005 US$) in South Asia and Value added (constant 2005 US$) in China?
Your answer should be compact. -2.87e+11. In the year 2002, what is the difference between the Value added (constant 2005 US$) in South Asia and Value added (constant 2005 US$) in Greece?
Your answer should be compact. 2.60e+11. In the year 2002, what is the difference between the Value added (constant 2005 US$) of Albania and Value added (constant 2005 US$) of China?
Provide a succinct answer. -6.90e+11. In the year 2002, what is the difference between the Value added (constant 2005 US$) in Albania and Value added (constant 2005 US$) in Greece?
Ensure brevity in your answer.  -1.42e+11. In the year 2002, what is the difference between the Value added (constant 2005 US$) in China and Value added (constant 2005 US$) in Greece?
Ensure brevity in your answer.  5.47e+11. In the year 2003, what is the difference between the Value added (constant 2005 US$) of South Asia and Value added (constant 2005 US$) of Albania?
Make the answer very short. 4.32e+11. In the year 2003, what is the difference between the Value added (constant 2005 US$) of South Asia and Value added (constant 2005 US$) of China?
Your response must be concise. -3.23e+11. In the year 2003, what is the difference between the Value added (constant 2005 US$) of South Asia and Value added (constant 2005 US$) of Greece?
Ensure brevity in your answer.  2.82e+11. In the year 2003, what is the difference between the Value added (constant 2005 US$) of Albania and Value added (constant 2005 US$) of China?
Offer a very short reply. -7.56e+11. In the year 2003, what is the difference between the Value added (constant 2005 US$) in Albania and Value added (constant 2005 US$) in Greece?
Offer a very short reply. -1.50e+11. In the year 2003, what is the difference between the Value added (constant 2005 US$) of China and Value added (constant 2005 US$) of Greece?
Ensure brevity in your answer.  6.06e+11. In the year 2004, what is the difference between the Value added (constant 2005 US$) of South Asia and Value added (constant 2005 US$) of Albania?
Make the answer very short. 4.66e+11. In the year 2004, what is the difference between the Value added (constant 2005 US$) of South Asia and Value added (constant 2005 US$) of China?
Your response must be concise. -3.66e+11. In the year 2004, what is the difference between the Value added (constant 2005 US$) of South Asia and Value added (constant 2005 US$) of Greece?
Offer a very short reply. 3.05e+11. In the year 2004, what is the difference between the Value added (constant 2005 US$) of Albania and Value added (constant 2005 US$) of China?
Your answer should be very brief. -8.33e+11. In the year 2004, what is the difference between the Value added (constant 2005 US$) of Albania and Value added (constant 2005 US$) of Greece?
Offer a terse response. -1.61e+11. In the year 2004, what is the difference between the Value added (constant 2005 US$) of China and Value added (constant 2005 US$) of Greece?
Keep it short and to the point. 6.72e+11. What is the ratio of the Value added (constant 2005 US$) of South Asia in 1997 to that in 1998?
Offer a very short reply. 0.93. What is the ratio of the Value added (constant 2005 US$) in Albania in 1997 to that in 1998?
Provide a succinct answer. 0.99. What is the ratio of the Value added (constant 2005 US$) in China in 1997 to that in 1998?
Provide a short and direct response. 0.92. What is the ratio of the Value added (constant 2005 US$) in Greece in 1997 to that in 1998?
Give a very brief answer. 0.95. What is the ratio of the Value added (constant 2005 US$) of South Asia in 1997 to that in 1999?
Ensure brevity in your answer.  0.85. What is the ratio of the Value added (constant 2005 US$) of Albania in 1997 to that in 1999?
Provide a succinct answer. 0.86. What is the ratio of the Value added (constant 2005 US$) in China in 1997 to that in 1999?
Ensure brevity in your answer.  0.84. What is the ratio of the Value added (constant 2005 US$) in Greece in 1997 to that in 1999?
Offer a very short reply. 0.95. What is the ratio of the Value added (constant 2005 US$) of South Asia in 1997 to that in 2000?
Provide a short and direct response. 0.81. What is the ratio of the Value added (constant 2005 US$) of Albania in 1997 to that in 2000?
Offer a very short reply. 0.82. What is the ratio of the Value added (constant 2005 US$) of China in 1997 to that in 2000?
Your answer should be compact. 0.77. What is the ratio of the Value added (constant 2005 US$) in Greece in 1997 to that in 2000?
Offer a very short reply. 0.92. What is the ratio of the Value added (constant 2005 US$) of South Asia in 1997 to that in 2001?
Your answer should be compact. 0.76. What is the ratio of the Value added (constant 2005 US$) in Albania in 1997 to that in 2001?
Provide a succinct answer. 0.75. What is the ratio of the Value added (constant 2005 US$) of China in 1997 to that in 2001?
Your response must be concise. 0.7. What is the ratio of the Value added (constant 2005 US$) of Greece in 1997 to that in 2001?
Provide a short and direct response. 0.89. What is the ratio of the Value added (constant 2005 US$) in South Asia in 1997 to that in 2002?
Your response must be concise. 0.72. What is the ratio of the Value added (constant 2005 US$) in Albania in 1997 to that in 2002?
Give a very brief answer. 0.7. What is the ratio of the Value added (constant 2005 US$) of China in 1997 to that in 2002?
Offer a terse response. 0.63. What is the ratio of the Value added (constant 2005 US$) in Greece in 1997 to that in 2002?
Provide a succinct answer. 0.86. What is the ratio of the Value added (constant 2005 US$) of South Asia in 1997 to that in 2003?
Offer a very short reply. 0.67. What is the ratio of the Value added (constant 2005 US$) of Albania in 1997 to that in 2003?
Make the answer very short. 0.74. What is the ratio of the Value added (constant 2005 US$) of China in 1997 to that in 2003?
Provide a succinct answer. 0.58. What is the ratio of the Value added (constant 2005 US$) in Greece in 1997 to that in 2003?
Your response must be concise. 0.81. What is the ratio of the Value added (constant 2005 US$) of South Asia in 1997 to that in 2004?
Offer a very short reply. 0.62. What is the ratio of the Value added (constant 2005 US$) in Albania in 1997 to that in 2004?
Your answer should be compact. 0.74. What is the ratio of the Value added (constant 2005 US$) in China in 1997 to that in 2004?
Provide a succinct answer. 0.52. What is the ratio of the Value added (constant 2005 US$) of Greece in 1997 to that in 2004?
Your answer should be compact. 0.76. What is the ratio of the Value added (constant 2005 US$) in South Asia in 1998 to that in 1999?
Offer a terse response. 0.91. What is the ratio of the Value added (constant 2005 US$) in Albania in 1998 to that in 1999?
Provide a short and direct response. 0.87. What is the ratio of the Value added (constant 2005 US$) in China in 1998 to that in 1999?
Ensure brevity in your answer.  0.92. What is the ratio of the Value added (constant 2005 US$) of Greece in 1998 to that in 1999?
Keep it short and to the point. 1. What is the ratio of the Value added (constant 2005 US$) of South Asia in 1998 to that in 2000?
Offer a terse response. 0.86. What is the ratio of the Value added (constant 2005 US$) of Albania in 1998 to that in 2000?
Offer a very short reply. 0.83. What is the ratio of the Value added (constant 2005 US$) in China in 1998 to that in 2000?
Make the answer very short. 0.83. What is the ratio of the Value added (constant 2005 US$) of Greece in 1998 to that in 2000?
Provide a succinct answer. 0.96. What is the ratio of the Value added (constant 2005 US$) in South Asia in 1998 to that in 2001?
Ensure brevity in your answer.  0.82. What is the ratio of the Value added (constant 2005 US$) in Albania in 1998 to that in 2001?
Offer a very short reply. 0.76. What is the ratio of the Value added (constant 2005 US$) in China in 1998 to that in 2001?
Ensure brevity in your answer.  0.76. What is the ratio of the Value added (constant 2005 US$) in Greece in 1998 to that in 2001?
Your response must be concise. 0.93. What is the ratio of the Value added (constant 2005 US$) of South Asia in 1998 to that in 2002?
Your response must be concise. 0.77. What is the ratio of the Value added (constant 2005 US$) in Albania in 1998 to that in 2002?
Your answer should be compact. 0.71. What is the ratio of the Value added (constant 2005 US$) in China in 1998 to that in 2002?
Your response must be concise. 0.69. What is the ratio of the Value added (constant 2005 US$) in Greece in 1998 to that in 2002?
Offer a very short reply. 0.9. What is the ratio of the Value added (constant 2005 US$) of South Asia in 1998 to that in 2003?
Ensure brevity in your answer.  0.72. What is the ratio of the Value added (constant 2005 US$) in Albania in 1998 to that in 2003?
Provide a short and direct response. 0.75. What is the ratio of the Value added (constant 2005 US$) in China in 1998 to that in 2003?
Keep it short and to the point. 0.63. What is the ratio of the Value added (constant 2005 US$) of Greece in 1998 to that in 2003?
Offer a very short reply. 0.85. What is the ratio of the Value added (constant 2005 US$) of South Asia in 1998 to that in 2004?
Make the answer very short. 0.66. What is the ratio of the Value added (constant 2005 US$) of Albania in 1998 to that in 2004?
Keep it short and to the point. 0.75. What is the ratio of the Value added (constant 2005 US$) of China in 1998 to that in 2004?
Your response must be concise. 0.57. What is the ratio of the Value added (constant 2005 US$) in Greece in 1998 to that in 2004?
Provide a short and direct response. 0.8. What is the ratio of the Value added (constant 2005 US$) in South Asia in 1999 to that in 2000?
Provide a succinct answer. 0.95. What is the ratio of the Value added (constant 2005 US$) in Albania in 1999 to that in 2000?
Offer a terse response. 0.96. What is the ratio of the Value added (constant 2005 US$) of China in 1999 to that in 2000?
Provide a short and direct response. 0.91. What is the ratio of the Value added (constant 2005 US$) in Greece in 1999 to that in 2000?
Offer a very short reply. 0.96. What is the ratio of the Value added (constant 2005 US$) of South Asia in 1999 to that in 2001?
Provide a short and direct response. 0.9. What is the ratio of the Value added (constant 2005 US$) in Albania in 1999 to that in 2001?
Give a very brief answer. 0.87. What is the ratio of the Value added (constant 2005 US$) in China in 1999 to that in 2001?
Offer a very short reply. 0.83. What is the ratio of the Value added (constant 2005 US$) in Greece in 1999 to that in 2001?
Your answer should be very brief. 0.93. What is the ratio of the Value added (constant 2005 US$) of South Asia in 1999 to that in 2002?
Your answer should be very brief. 0.85. What is the ratio of the Value added (constant 2005 US$) of Albania in 1999 to that in 2002?
Offer a terse response. 0.82. What is the ratio of the Value added (constant 2005 US$) in China in 1999 to that in 2002?
Make the answer very short. 0.75. What is the ratio of the Value added (constant 2005 US$) in Greece in 1999 to that in 2002?
Ensure brevity in your answer.  0.9. What is the ratio of the Value added (constant 2005 US$) in South Asia in 1999 to that in 2003?
Your answer should be compact. 0.79. What is the ratio of the Value added (constant 2005 US$) in Albania in 1999 to that in 2003?
Ensure brevity in your answer.  0.86. What is the ratio of the Value added (constant 2005 US$) in China in 1999 to that in 2003?
Offer a terse response. 0.68. What is the ratio of the Value added (constant 2005 US$) in Greece in 1999 to that in 2003?
Provide a succinct answer. 0.85. What is the ratio of the Value added (constant 2005 US$) of South Asia in 1999 to that in 2004?
Offer a very short reply. 0.73. What is the ratio of the Value added (constant 2005 US$) in Albania in 1999 to that in 2004?
Offer a terse response. 0.86. What is the ratio of the Value added (constant 2005 US$) of China in 1999 to that in 2004?
Your answer should be compact. 0.62. What is the ratio of the Value added (constant 2005 US$) of Greece in 1999 to that in 2004?
Your response must be concise. 0.8. What is the ratio of the Value added (constant 2005 US$) in South Asia in 2000 to that in 2001?
Your response must be concise. 0.94. What is the ratio of the Value added (constant 2005 US$) of Albania in 2000 to that in 2001?
Your response must be concise. 0.91. What is the ratio of the Value added (constant 2005 US$) of China in 2000 to that in 2001?
Your answer should be compact. 0.91. What is the ratio of the Value added (constant 2005 US$) in Greece in 2000 to that in 2001?
Give a very brief answer. 0.97. What is the ratio of the Value added (constant 2005 US$) of South Asia in 2000 to that in 2002?
Your response must be concise. 0.89. What is the ratio of the Value added (constant 2005 US$) in Albania in 2000 to that in 2002?
Provide a succinct answer. 0.86. What is the ratio of the Value added (constant 2005 US$) in China in 2000 to that in 2002?
Provide a succinct answer. 0.82. What is the ratio of the Value added (constant 2005 US$) in Greece in 2000 to that in 2002?
Ensure brevity in your answer.  0.93. What is the ratio of the Value added (constant 2005 US$) of South Asia in 2000 to that in 2003?
Provide a short and direct response. 0.83. What is the ratio of the Value added (constant 2005 US$) in Albania in 2000 to that in 2003?
Your response must be concise. 0.9. What is the ratio of the Value added (constant 2005 US$) in China in 2000 to that in 2003?
Your answer should be very brief. 0.75. What is the ratio of the Value added (constant 2005 US$) of Greece in 2000 to that in 2003?
Keep it short and to the point. 0.89. What is the ratio of the Value added (constant 2005 US$) of South Asia in 2000 to that in 2004?
Your answer should be very brief. 0.77. What is the ratio of the Value added (constant 2005 US$) of Albania in 2000 to that in 2004?
Offer a very short reply. 0.9. What is the ratio of the Value added (constant 2005 US$) of China in 2000 to that in 2004?
Offer a very short reply. 0.68. What is the ratio of the Value added (constant 2005 US$) in Greece in 2000 to that in 2004?
Make the answer very short. 0.83. What is the ratio of the Value added (constant 2005 US$) in South Asia in 2001 to that in 2002?
Ensure brevity in your answer.  0.94. What is the ratio of the Value added (constant 2005 US$) in Albania in 2001 to that in 2002?
Provide a short and direct response. 0.94. What is the ratio of the Value added (constant 2005 US$) in China in 2001 to that in 2002?
Keep it short and to the point. 0.91. What is the ratio of the Value added (constant 2005 US$) in Greece in 2001 to that in 2002?
Provide a succinct answer. 0.96. What is the ratio of the Value added (constant 2005 US$) of South Asia in 2001 to that in 2003?
Give a very brief answer. 0.88. What is the ratio of the Value added (constant 2005 US$) in Albania in 2001 to that in 2003?
Your answer should be very brief. 0.99. What is the ratio of the Value added (constant 2005 US$) in China in 2001 to that in 2003?
Provide a succinct answer. 0.83. What is the ratio of the Value added (constant 2005 US$) of Greece in 2001 to that in 2003?
Offer a terse response. 0.91. What is the ratio of the Value added (constant 2005 US$) in South Asia in 2001 to that in 2004?
Your answer should be compact. 0.81. What is the ratio of the Value added (constant 2005 US$) of Albania in 2001 to that in 2004?
Offer a very short reply. 0.99. What is the ratio of the Value added (constant 2005 US$) of China in 2001 to that in 2004?
Ensure brevity in your answer.  0.75. What is the ratio of the Value added (constant 2005 US$) of Greece in 2001 to that in 2004?
Offer a terse response. 0.85. What is the ratio of the Value added (constant 2005 US$) of South Asia in 2002 to that in 2003?
Your answer should be very brief. 0.93. What is the ratio of the Value added (constant 2005 US$) of Albania in 2002 to that in 2003?
Provide a short and direct response. 1.05. What is the ratio of the Value added (constant 2005 US$) in South Asia in 2002 to that in 2004?
Provide a short and direct response. 0.86. What is the ratio of the Value added (constant 2005 US$) of Albania in 2002 to that in 2004?
Keep it short and to the point. 1.05. What is the ratio of the Value added (constant 2005 US$) of China in 2002 to that in 2004?
Offer a terse response. 0.83. What is the ratio of the Value added (constant 2005 US$) of Greece in 2002 to that in 2004?
Offer a very short reply. 0.89. What is the ratio of the Value added (constant 2005 US$) of South Asia in 2003 to that in 2004?
Your response must be concise. 0.93. What is the ratio of the Value added (constant 2005 US$) of Albania in 2003 to that in 2004?
Offer a terse response. 1. What is the ratio of the Value added (constant 2005 US$) of China in 2003 to that in 2004?
Your answer should be compact. 0.91. What is the ratio of the Value added (constant 2005 US$) in Greece in 2003 to that in 2004?
Provide a short and direct response. 0.94. What is the difference between the highest and the second highest Value added (constant 2005 US$) in South Asia?
Your response must be concise. 3.37e+1. What is the difference between the highest and the second highest Value added (constant 2005 US$) in Albania?
Offer a terse response. 1.90e+08. What is the difference between the highest and the second highest Value added (constant 2005 US$) of China?
Offer a very short reply. 7.66e+1. What is the difference between the highest and the second highest Value added (constant 2005 US$) in Greece?
Provide a succinct answer. 1.05e+1. What is the difference between the highest and the lowest Value added (constant 2005 US$) in South Asia?
Offer a terse response. 1.78e+11. What is the difference between the highest and the lowest Value added (constant 2005 US$) of Albania?
Keep it short and to the point. 1.13e+09. What is the difference between the highest and the lowest Value added (constant 2005 US$) of China?
Provide a short and direct response. 3.98e+11. What is the difference between the highest and the lowest Value added (constant 2005 US$) in Greece?
Your answer should be compact. 3.94e+1. 